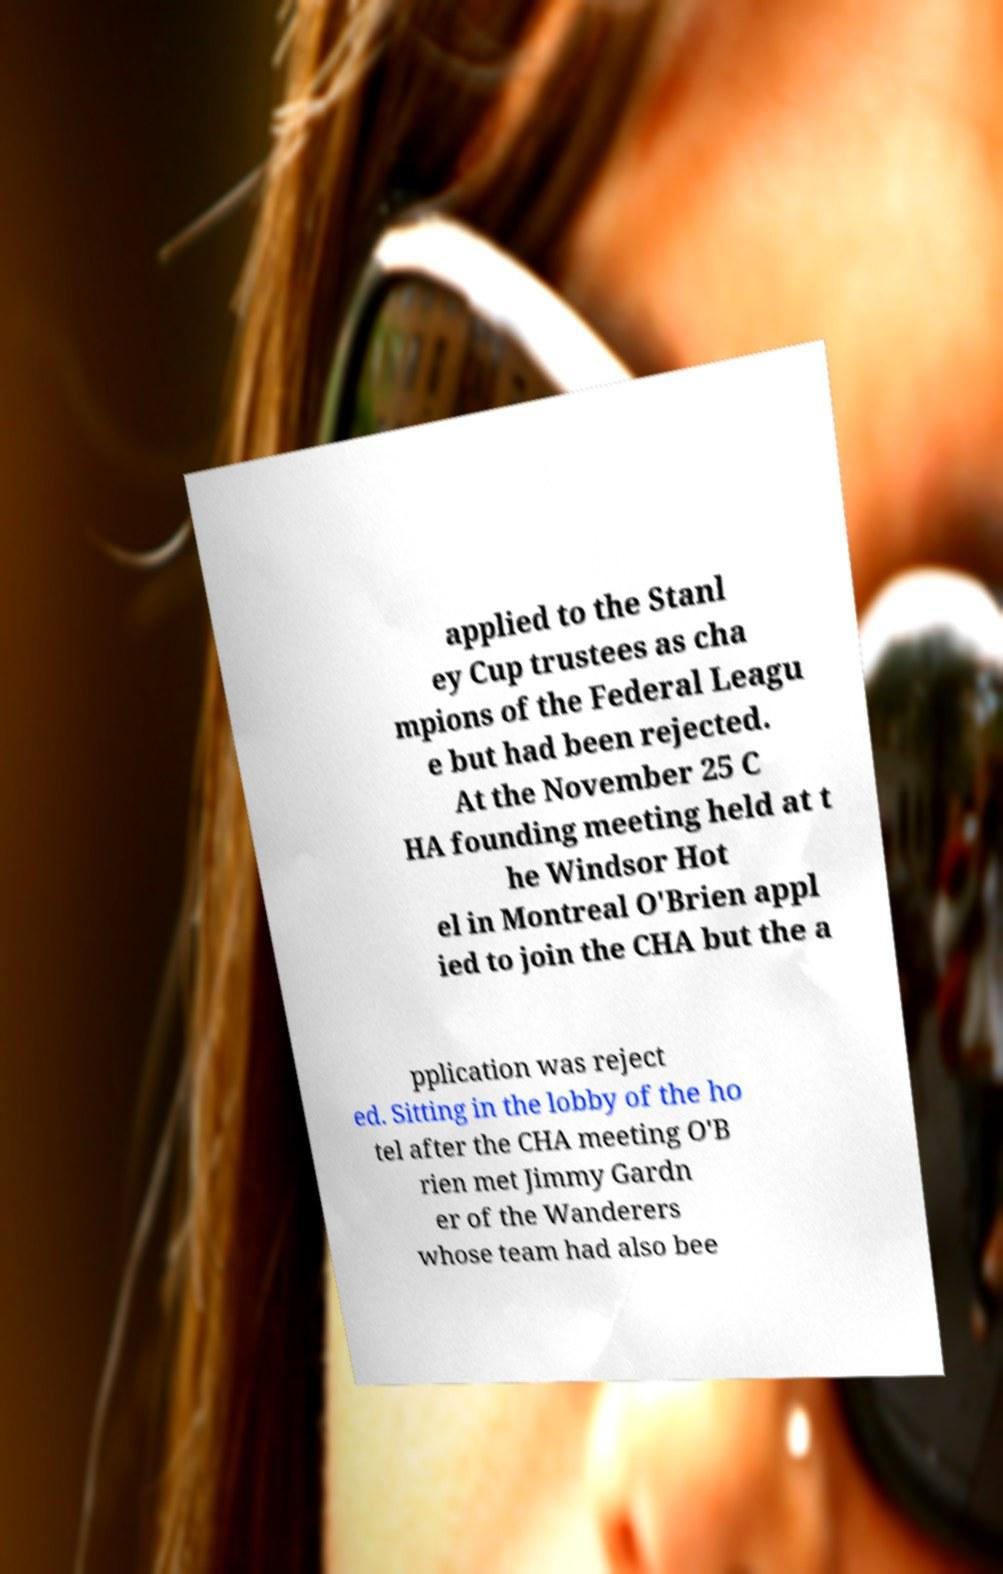Could you assist in decoding the text presented in this image and type it out clearly? applied to the Stanl ey Cup trustees as cha mpions of the Federal Leagu e but had been rejected. At the November 25 C HA founding meeting held at t he Windsor Hot el in Montreal O'Brien appl ied to join the CHA but the a pplication was reject ed. Sitting in the lobby of the ho tel after the CHA meeting O'B rien met Jimmy Gardn er of the Wanderers whose team had also bee 